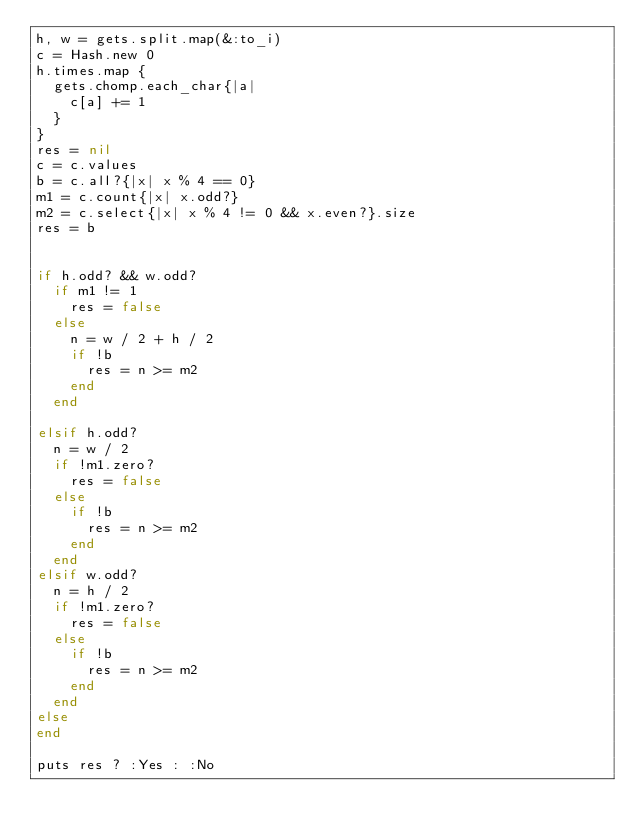<code> <loc_0><loc_0><loc_500><loc_500><_Ruby_>h, w = gets.split.map(&:to_i)
c = Hash.new 0
h.times.map {
  gets.chomp.each_char{|a|
    c[a] += 1
  }
}
res = nil
c = c.values
b = c.all?{|x| x % 4 == 0}
m1 = c.count{|x| x.odd?}
m2 = c.select{|x| x % 4 != 0 && x.even?}.size
res = b


if h.odd? && w.odd?
  if m1 != 1
    res = false
  else
    n = w / 2 + h / 2
    if !b
      res = n >= m2
    end
  end

elsif h.odd?
  n = w / 2
  if !m1.zero?
    res = false
  else
    if !b
      res = n >= m2
    end
  end
elsif w.odd?
  n = h / 2
  if !m1.zero?
    res = false
  else
    if !b
      res = n >= m2
    end
  end
else
end

puts res ? :Yes : :No</code> 